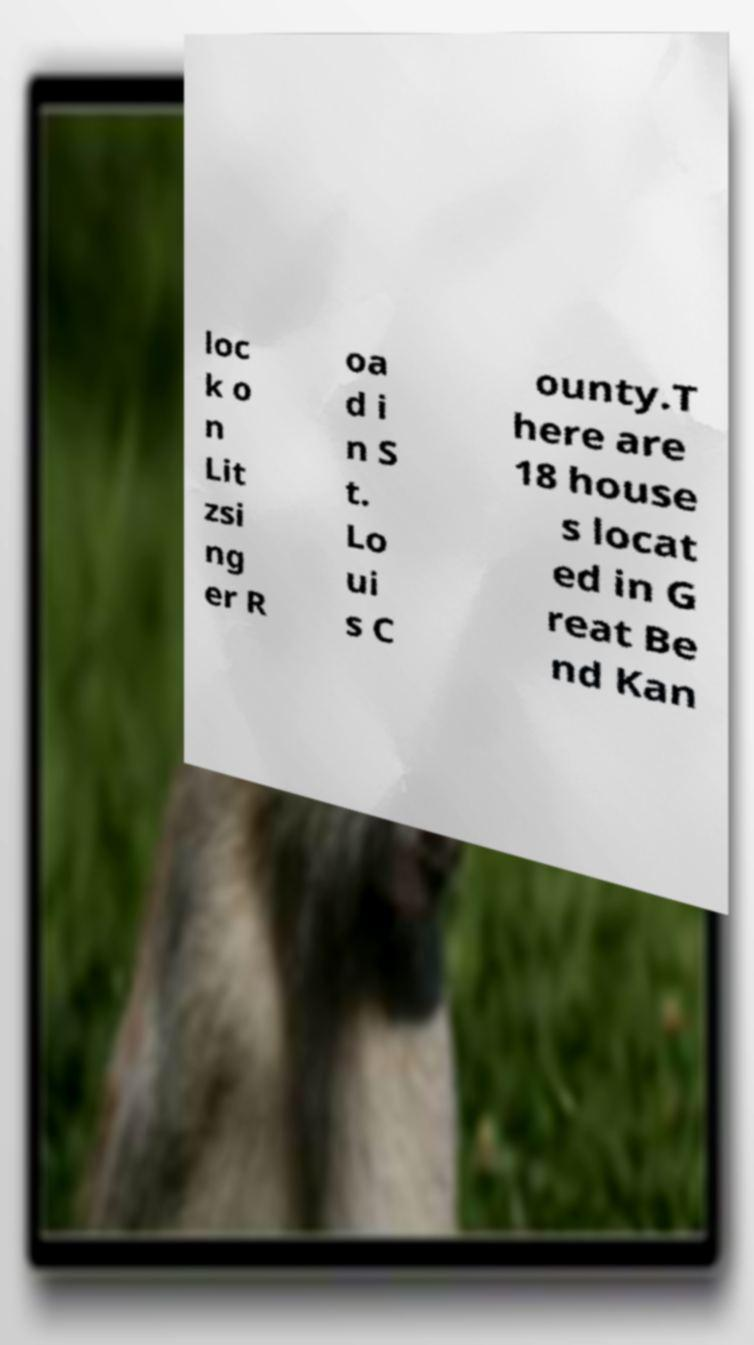Could you assist in decoding the text presented in this image and type it out clearly? loc k o n Lit zsi ng er R oa d i n S t. Lo ui s C ounty.T here are 18 house s locat ed in G reat Be nd Kan 